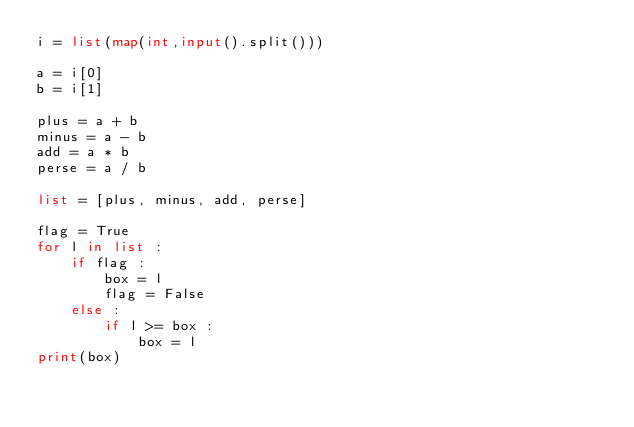Convert code to text. <code><loc_0><loc_0><loc_500><loc_500><_Python_>i = list(map(int,input().split()))

a = i[0]
b = i[1]

plus = a + b
minus = a - b
add = a * b
perse = a / b

list = [plus, minus, add, perse]

flag = True
for l in list :
    if flag :
        box = l
        flag = False
    else :
        if l >= box :
            box = l
print(box)</code> 